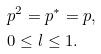<formula> <loc_0><loc_0><loc_500><loc_500>& p ^ { 2 } = p ^ { * } = p , \\ & 0 \leq l \leq 1 .</formula> 